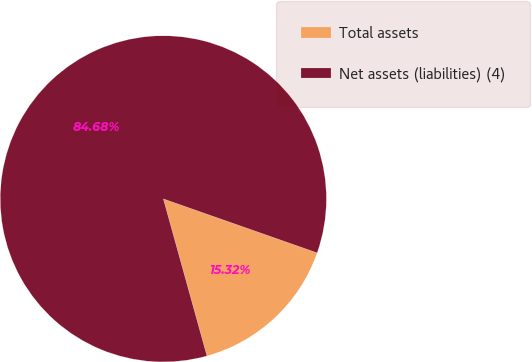<chart> <loc_0><loc_0><loc_500><loc_500><pie_chart><fcel>Total assets<fcel>Net assets (liabilities) (4)<nl><fcel>15.32%<fcel>84.68%<nl></chart> 